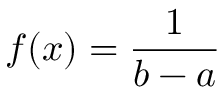<formula> <loc_0><loc_0><loc_500><loc_500>f ( x ) = { \frac { 1 } { b - a } }</formula> 